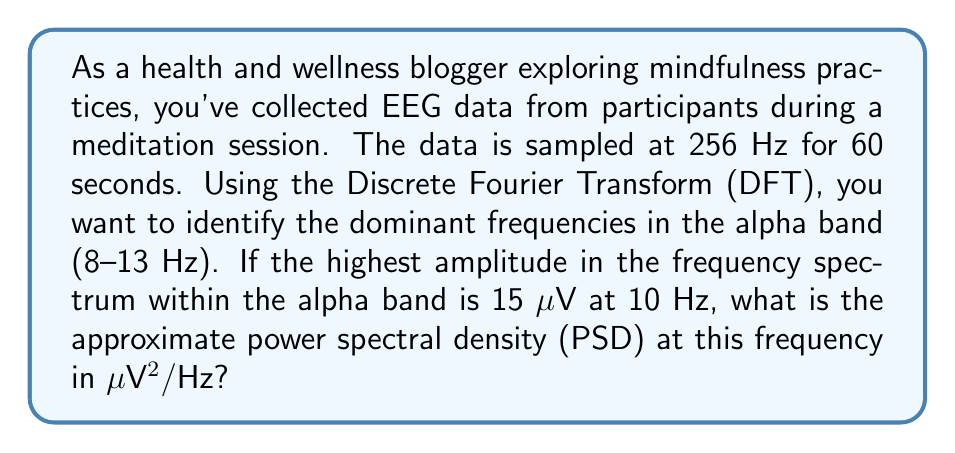Help me with this question. To solve this problem, we need to follow these steps:

1) First, let's recall the relationship between the DFT and PSD:

   $$ PSD(f) = \frac{|X(f)|^2}{N \cdot f_s} $$

   where $|X(f)|$ is the magnitude of the DFT, $N$ is the number of samples, and $f_s$ is the sampling frequency.

2) Calculate the number of samples:
   $N = 256 \text{ Hz} \cdot 60 \text{ s} = 15360$ samples

3) We're given that the highest amplitude in the alpha band is 15 μV at 10 Hz. In the context of the DFT, this amplitude corresponds to $|X(f)|/2$ (because the DFT considers both positive and negative frequencies).

   So, $|X(10 \text{ Hz})| = 2 \cdot 15 \text{ μV} = 30 \text{ μV}$

4) Now we can substitute these values into the PSD formula:

   $$ PSD(10 \text{ Hz}) = \frac{(30 \text{ μV})^2}{15360 \cdot 256 \text{ Hz}} $$

5) Simplify:
   $$ PSD(10 \text{ Hz}) = \frac{900 \text{ μV}^2}{3932160 \text{ Hz}} \approx 0.000229 \text{ μV}^2/\text{Hz} $$

6) Convert to more suitable units:
   $$ 0.000229 \text{ μV}^2/\text{Hz} \approx 0.229 \text{ μV}^2/\text{Hz} $$
Answer: The approximate power spectral density at 10 Hz is 0.229 μV²/Hz. 